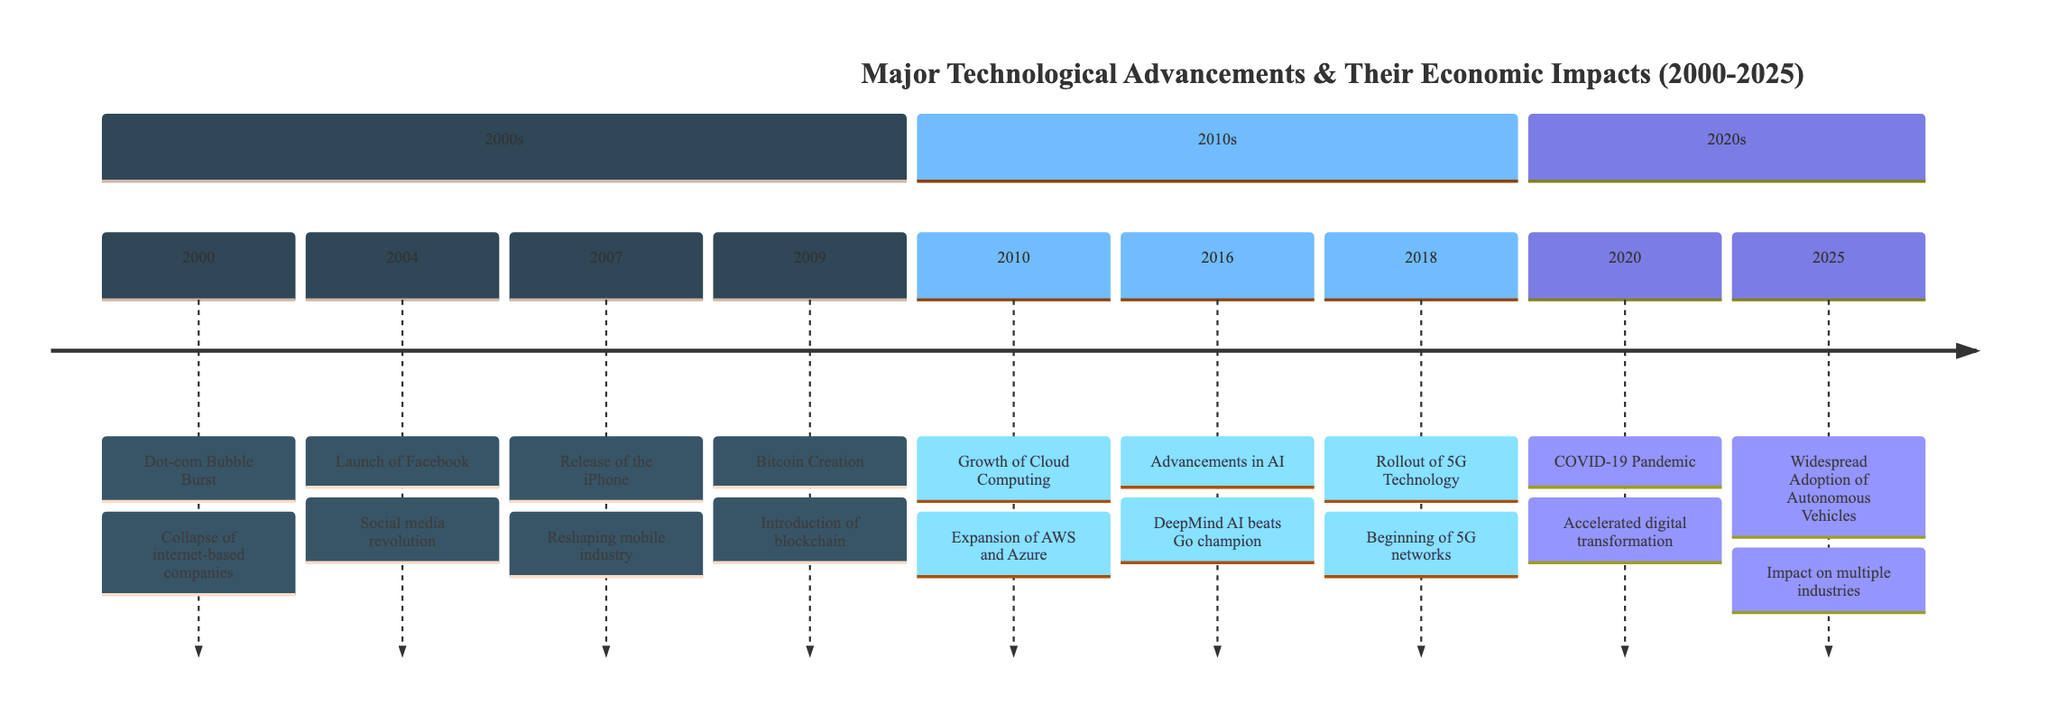What event occurred in 2000? The diagram lists "Dot-com Bubble Burst" as the event in the year 2000.
Answer: Dot-com Bubble Burst How many events are listed in the 2010s section? By counting the events in the 2010s section, we find three: Growth of Cloud Computing, Advancements in Artificial Intelligence, and Rollout of 5G Technology.
Answer: 3 What major technology was introduced in 2004? The diagram indicates that Facebook was launched in 2004.
Answer: Facebook Which event marks a significant shift towards digital transformation in 2020? The diagram shows that the COVID-19 Pandemic in 2020 caused an acceleration in digital transformation.
Answer: COVID-19 Pandemic What is the expected significant technological advancement in 2025? According to the diagram, the Widespread Adoption of Autonomous Vehicles is anticipated in 2025.
Answer: Widespread Adoption of Autonomous Vehicles What relationship do the iPhone release and the app-based economy have? The iPhone's release in 2007 reshaped the mobile industry and stimulated the app-based economy, fostering growth in telecommunications.
Answer: Stimulated the app-based economy How has the Bitcoin creation event in 2009 influenced investments? The introduction of Bitcoin and blockchain technology has led to substantial investments in fintech as shown in the diagram.
Answer: Substantial investments in fintech Which event directly relates to the advancements in AI in 2016? The diagram shows that Google's DeepMind AI defeating a human champion in Go was the significant AI advancement in 2016.
Answer: DeepMind AI defeats human champion What sections are included in the timeline? The timeline is divided into three sections: 2000s, 2010s, and 2020s.
Answer: 2000s, 2010s, 2020s 